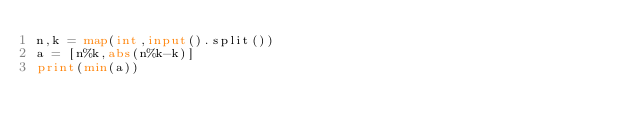<code> <loc_0><loc_0><loc_500><loc_500><_Python_>n,k = map(int,input().split())
a = [n%k,abs(n%k-k)]
print(min(a))</code> 